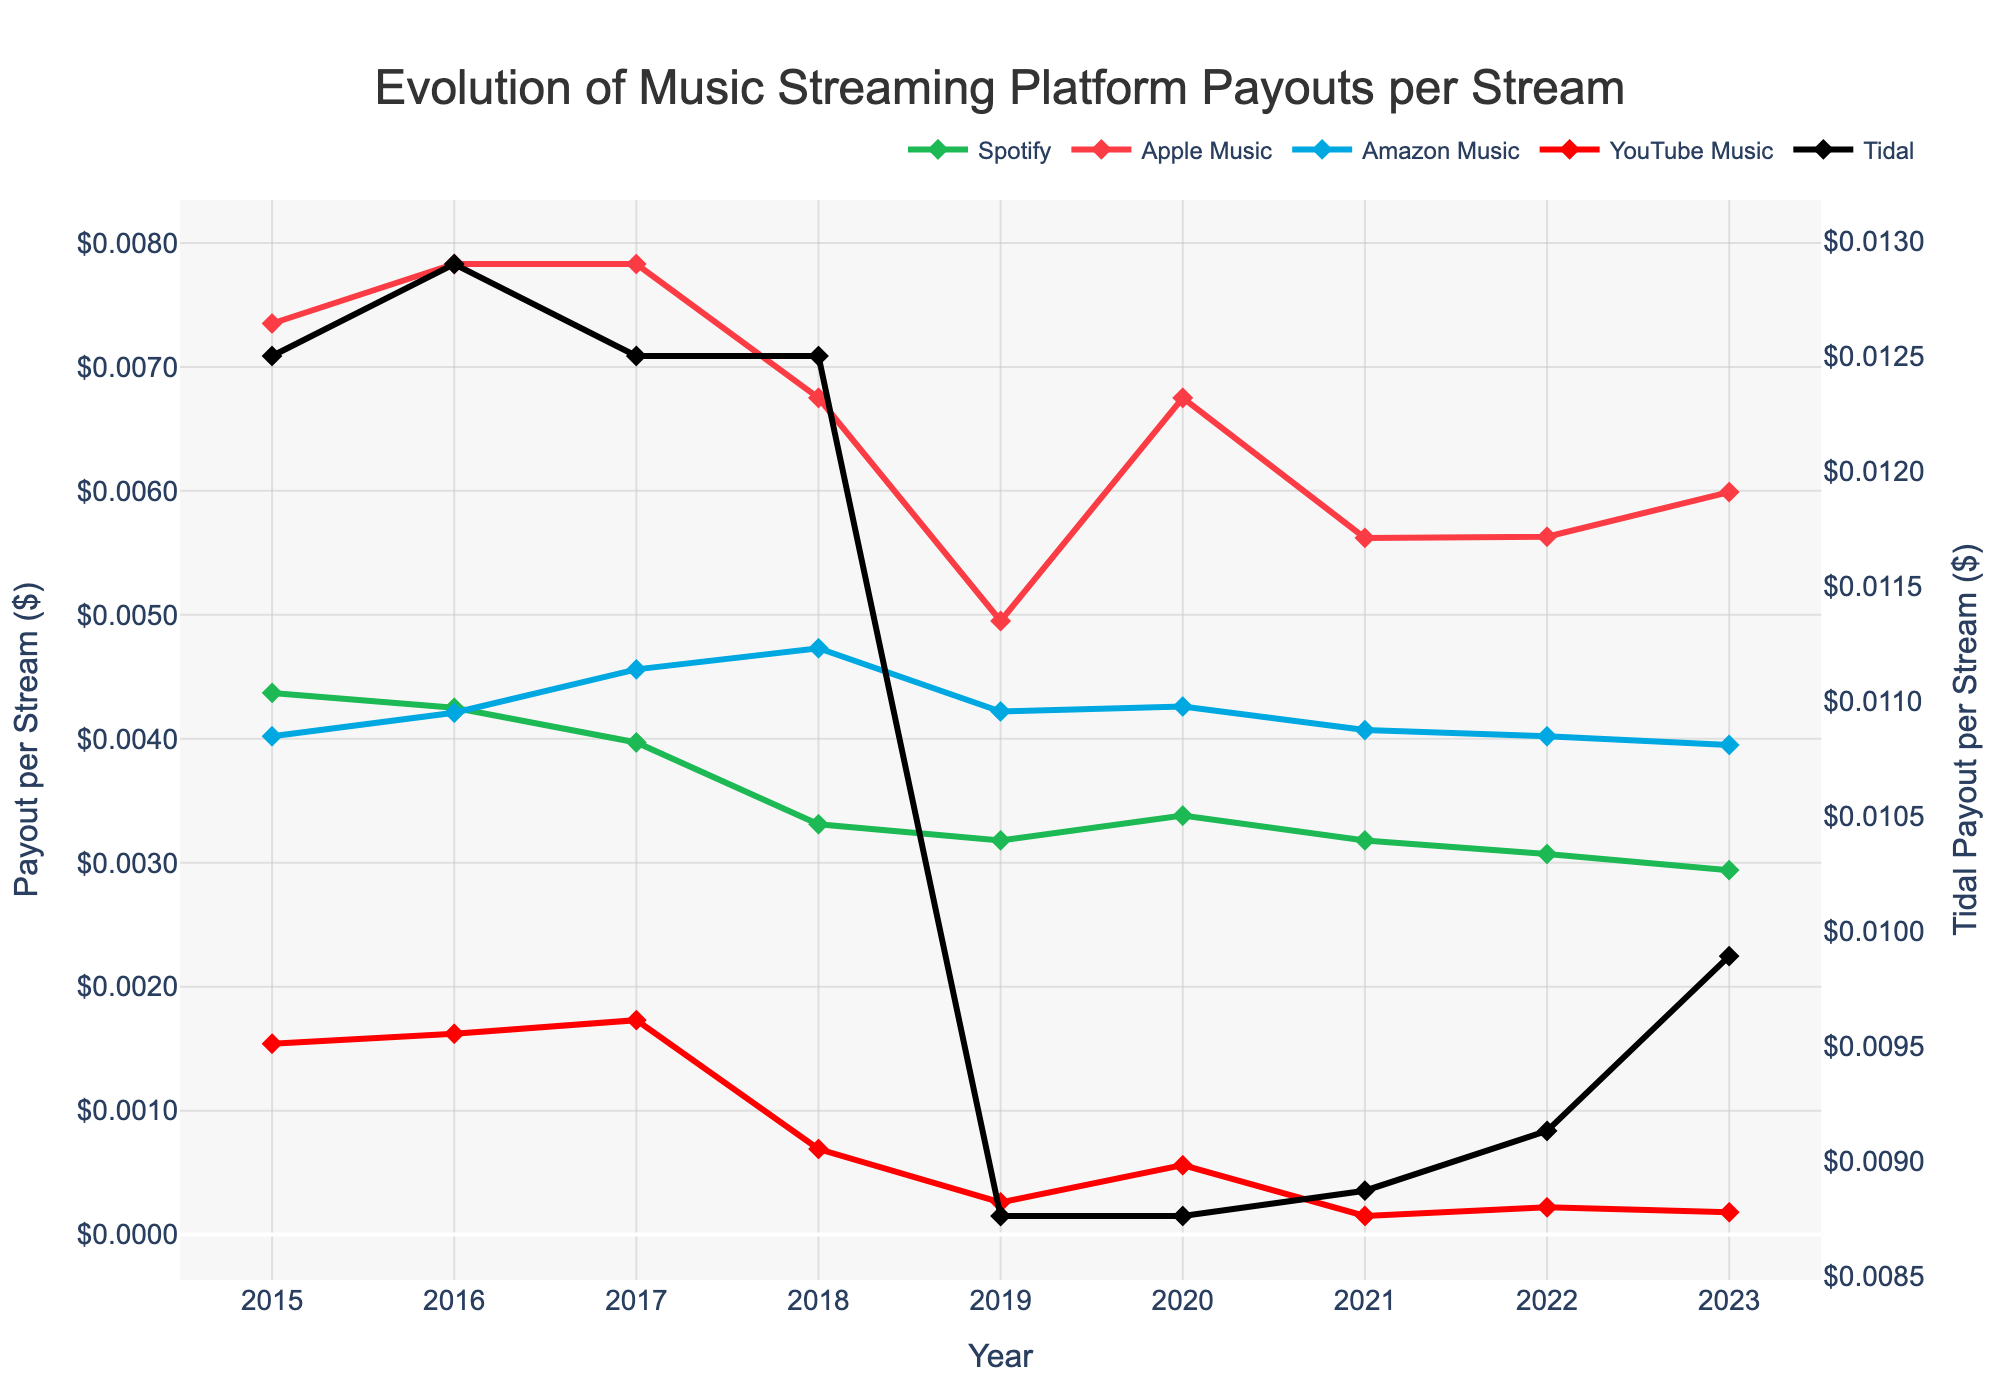What is the general trend of Spotify's payout per stream from 2015 to 2023? By observing the plot, you can see that Spotify's payout per stream shows a downward trend from 2015 to 2023. The line representing Spotify starts at approximately $0.00437 in 2015 and decreases to about $0.00294 by 2023.
Answer: Downward trend Which platform had the highest payout per stream in 2015, and what was the value? The platform with the highest payout per stream in 2015 is Tidal, as indicated by the highest point on the vertical axis for that year. The value for Tidal in 2015 is $0.0125.
Answer: Tidal, $0.0125 How does the payout per stream for YouTube Music in 2021 compare to the payout in 2020? To compare the payouts for YouTube Music between 2021 and 2020, locate the points for YouTube Music (red line) for these years. In 2020, the payout is approximately $0.00056, and in 2021, it is around $0.00015. The payout decreased from 2020 to 2021.
Answer: Decreased Calculate the average payout per stream for Apple Music from 2015 to 2023. To get the average payout for Apple Music, sum the payout values from 2015 to 2023 and divide by the number of years. The values are $0.00735, $0.00783, $0.00783, $0.00675, $0.00495, $0.00675, $0.00562, $0.00563, and $0.00599. Sum = 0.00735 + 0.00783 + 0.00783 + 0.00675 + 0.00495 + 0.00675 + 0.00562 + 0.00563 + 0.00599 = 0.0587. The average is 0.0587 / 9 ≈ 0.00652.
Answer: ~0.00652 Which year had the lowest payout per stream for Amazon Music, and what was the value? Observing the line for Amazon Music, the lowest point occurs in 2023. The payout value for Amazon Music in 2023 is approximately $0.00395.
Answer: 2023, $0.00395 Compare the payout per stream for Tidal and Spotify in 2023. Which one is higher and by how much? To compare Tidal and Spotify in 2023, locate their values for that year. Tidal's payout is $0.00989, and Spotify's payout is $0.00294. Tidal's payout is higher by 0.00989 - 0.00294 = 0.00695.
Answer: Tidal, $0.00695 What is the overall trend for Apple Music's payout per stream from 2015 to 2023? By examining the trend for Apple Music (orange line), it shows some fluctuations but generally a slight downward trend. It starts at $0.00735 in 2015 and ends at $0.00599 in 2023.
Answer: Slight downward trend Identify the year when YouTube Music had the lowest payout per stream and state the value. The lowest point for YouTube Music (red line) is in 2021. The value in 2021 is $0.00015.
Answer: 2021, $0.00015 How does the trend of Tidal's payout per stream from 2015 to 2023 compare to the trends of other platforms? Tidal's payout per stream has a noticeable larger fluctuation compared to other platforms, especially a significant drop after 2018. It remains the highest payout per stream overall but shows a decrease in 2019 that persists. Other platforms have more of a general downward trend but are less volatile.
Answer: More fluctuating, highest overall 